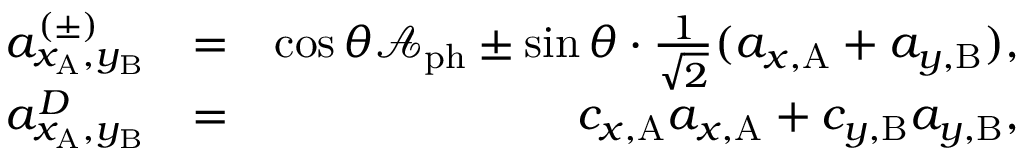<formula> <loc_0><loc_0><loc_500><loc_500>\begin{array} { r l r } { a _ { x _ { A } , y _ { B } } ^ { ( \pm ) } } & { = } & { \cos { \theta } \mathcal { A } _ { p h } \pm \sin { \theta } \cdot \frac { 1 } { \sqrt { 2 } } ( a _ { x , A } + a _ { y , B } ) , } \\ { a _ { x _ { A } , y _ { B } } ^ { D } } & { = } & { c _ { x , A } a _ { x , A } + c _ { y , B } a _ { y , B } , } \end{array}</formula> 